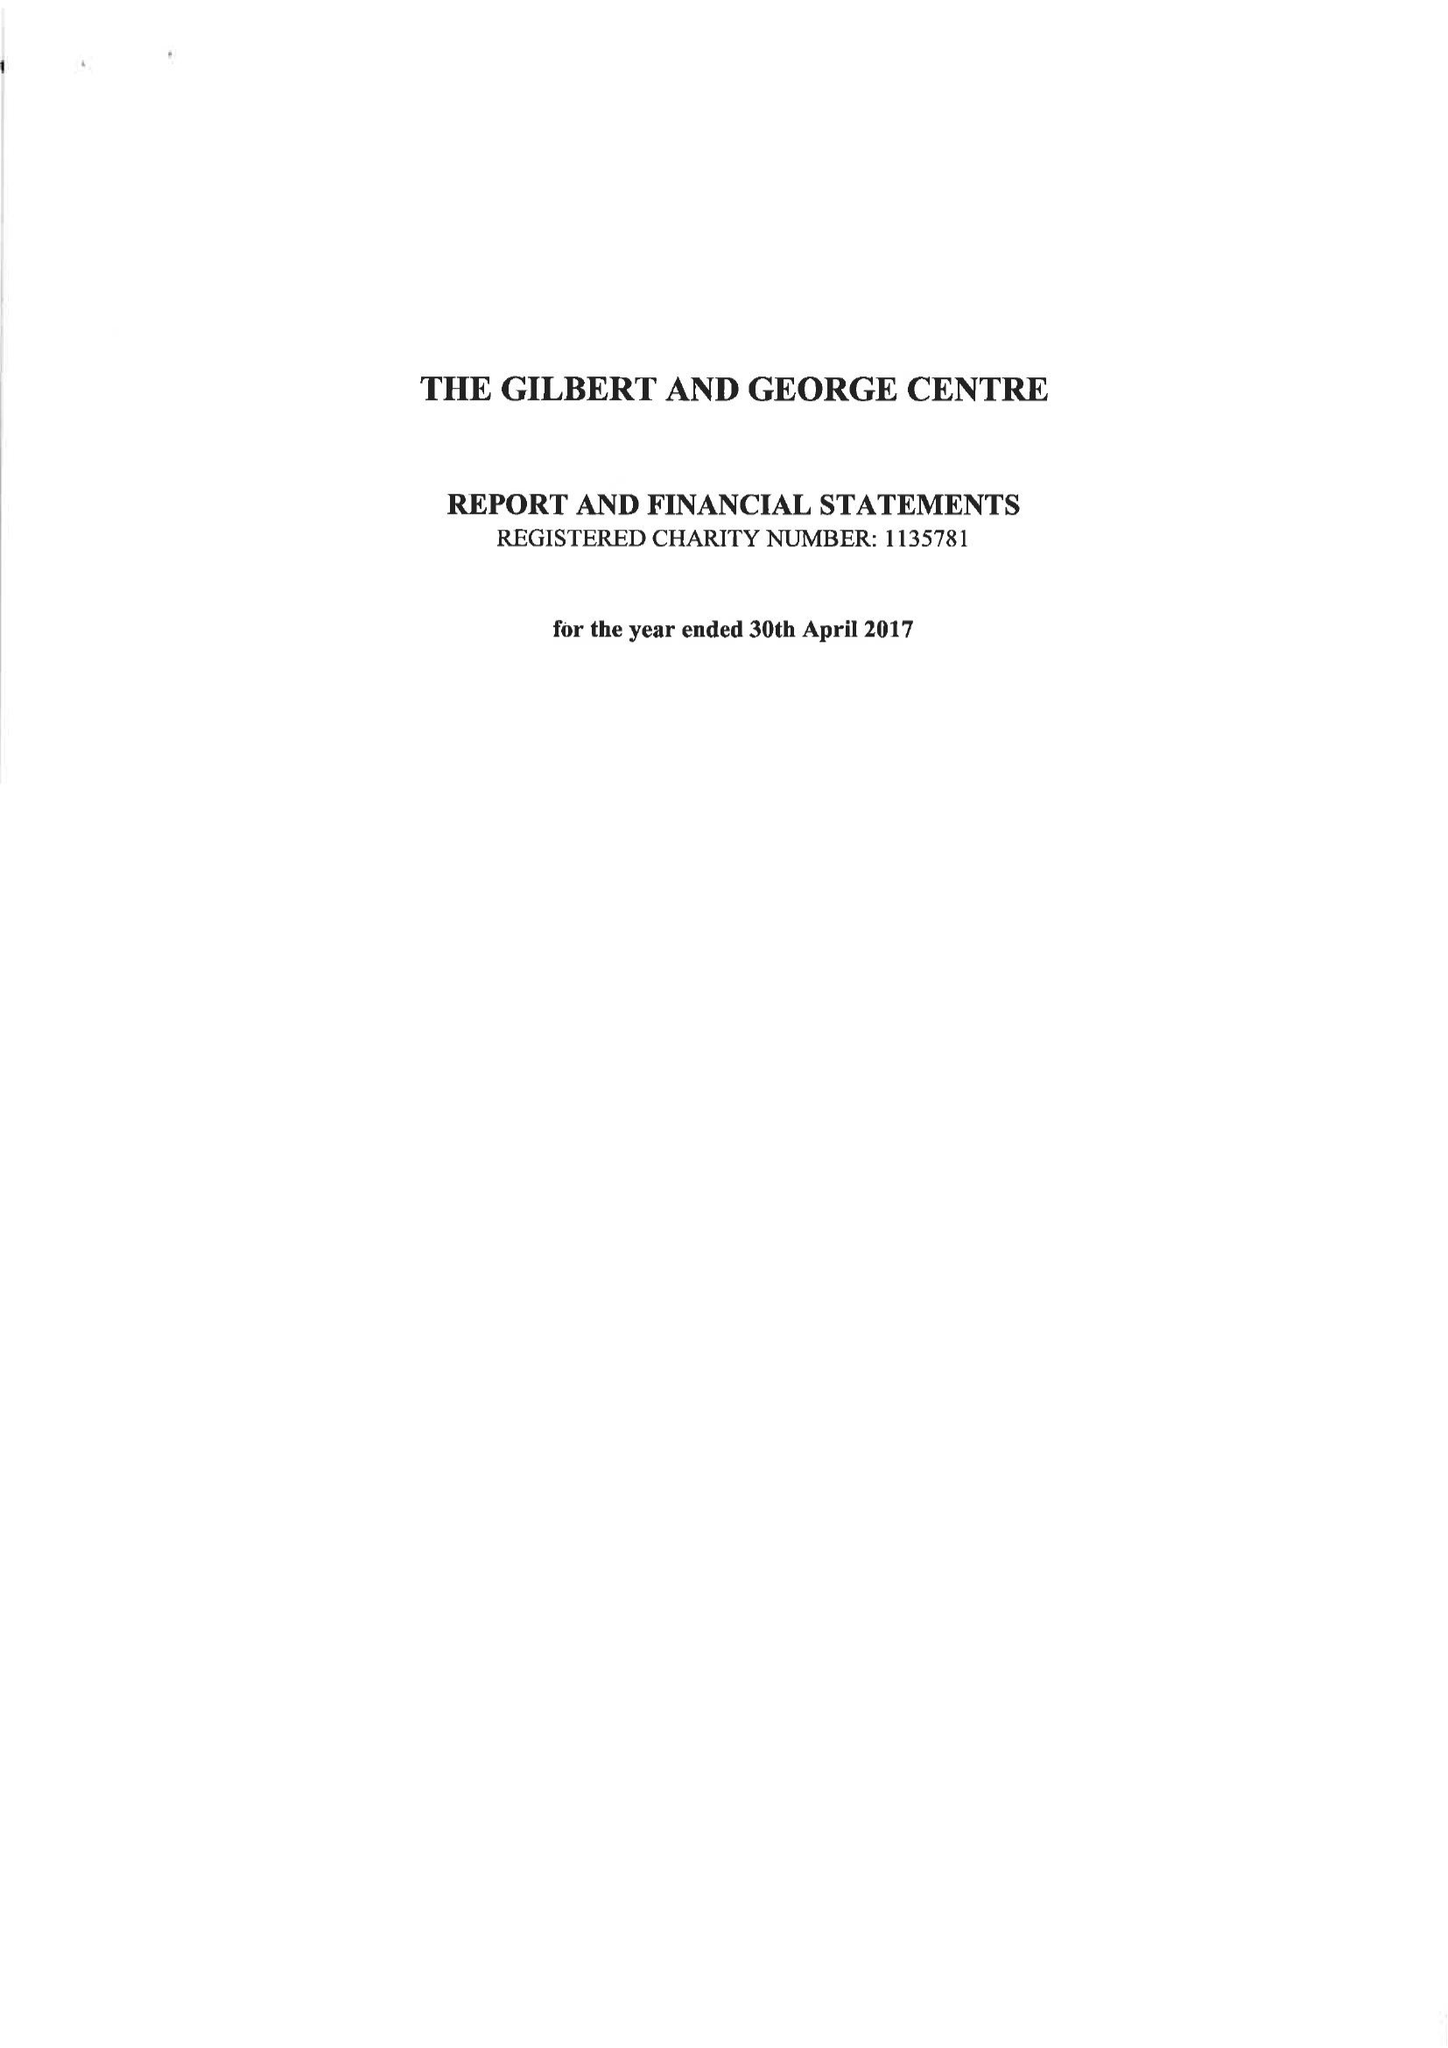What is the value for the address__street_line?
Answer the question using a single word or phrase. 12 FOURNIER STREET 